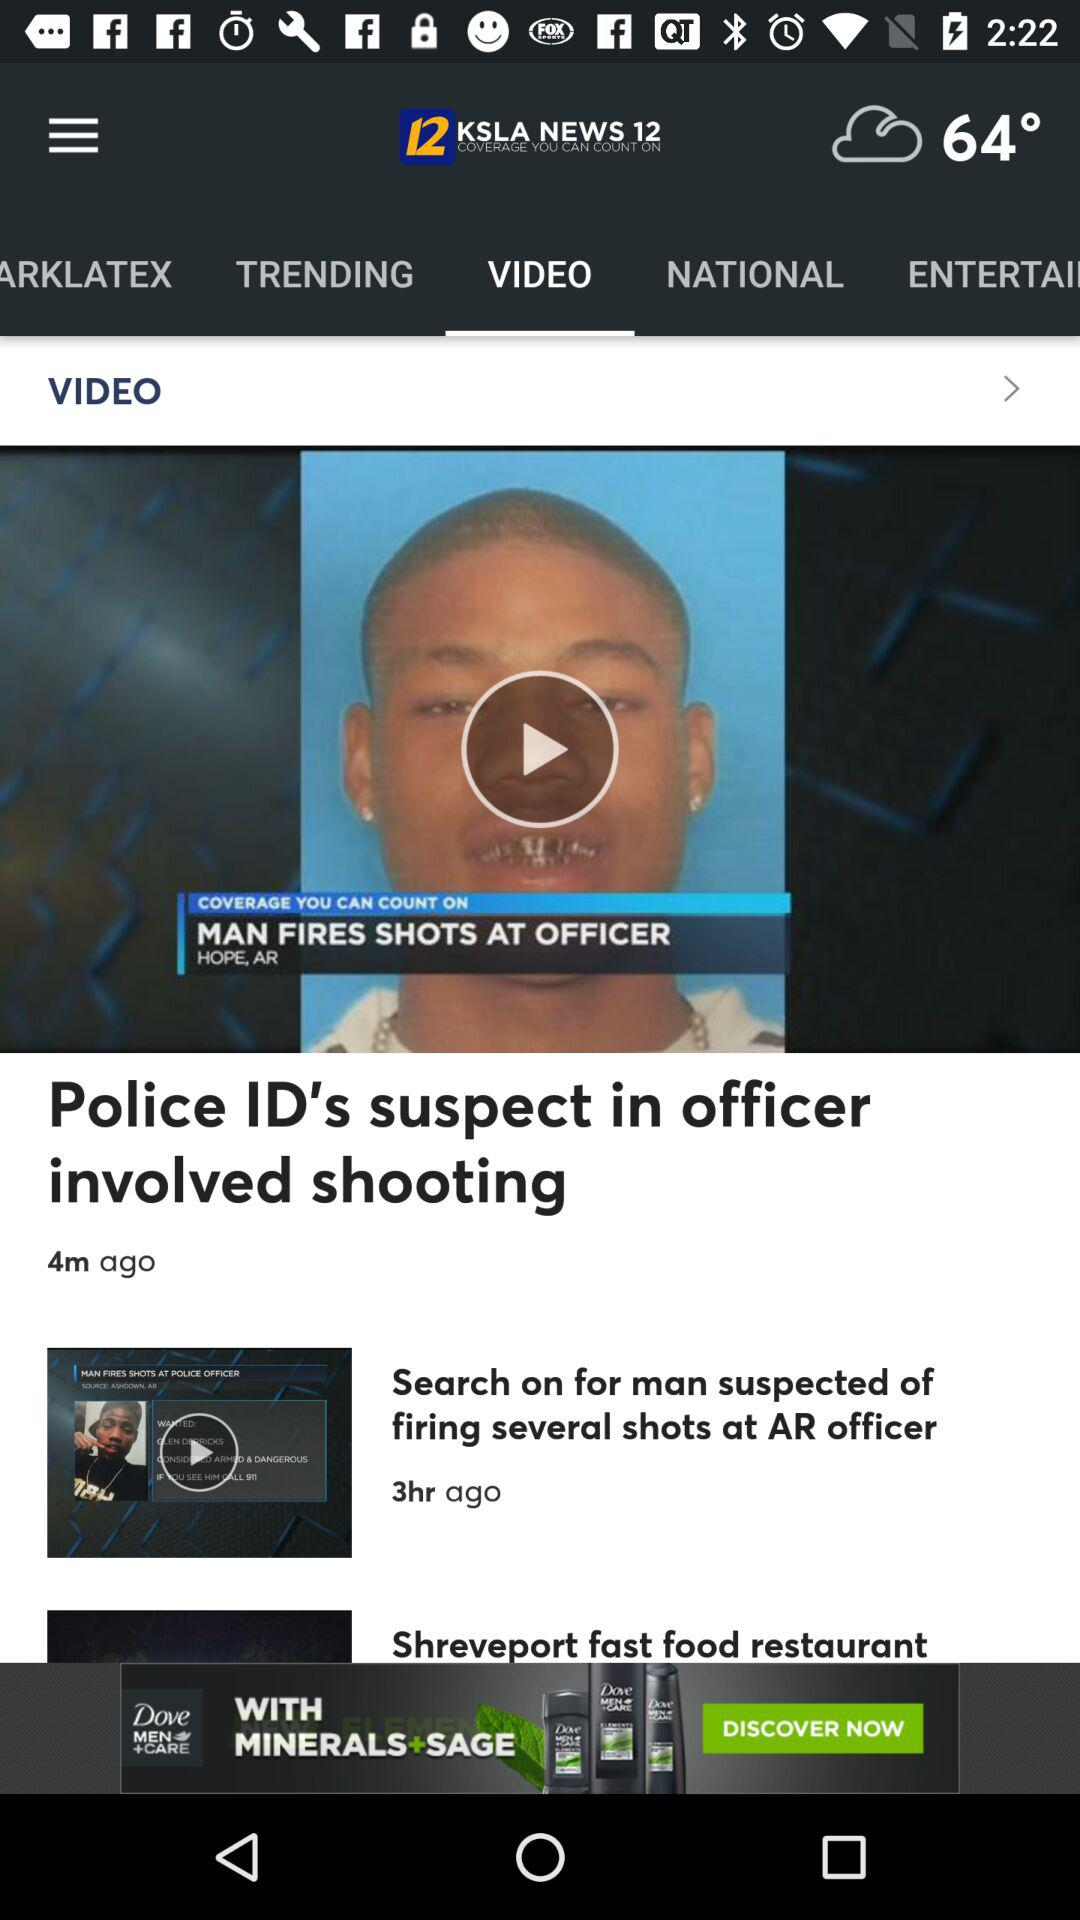How many notifications are there in "NATIONAL"?
When the provided information is insufficient, respond with <no answer>. <no answer> 